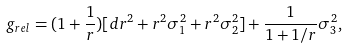<formula> <loc_0><loc_0><loc_500><loc_500>g _ { r e l } = ( 1 + \frac { 1 } { r } ) [ d r ^ { 2 } + r ^ { 2 } \sigma _ { 1 } ^ { 2 } + r ^ { 2 } \sigma _ { 2 } ^ { 2 } ] + \frac { 1 } { 1 + 1 / r } \sigma _ { 3 } ^ { 2 } ,</formula> 